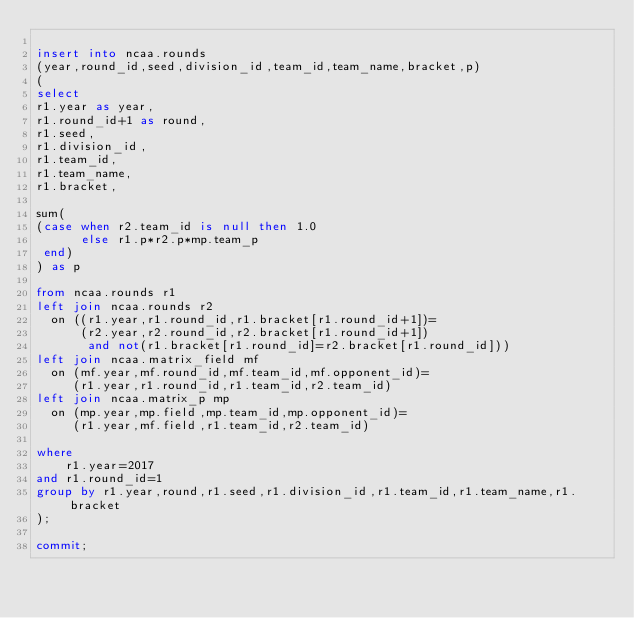<code> <loc_0><loc_0><loc_500><loc_500><_SQL_>
insert into ncaa.rounds
(year,round_id,seed,division_id,team_id,team_name,bracket,p)
(
select
r1.year as year,
r1.round_id+1 as round,
r1.seed,
r1.division_id,
r1.team_id,
r1.team_name,
r1.bracket,

sum(
(case when r2.team_id is null then 1.0
      else r1.p*r2.p*mp.team_p
 end)
) as p

from ncaa.rounds r1
left join ncaa.rounds r2
  on ((r1.year,r1.round_id,r1.bracket[r1.round_id+1])=
      (r2.year,r2.round_id,r2.bracket[r1.round_id+1])
       and not(r1.bracket[r1.round_id]=r2.bracket[r1.round_id]))
left join ncaa.matrix_field mf
  on (mf.year,mf.round_id,mf.team_id,mf.opponent_id)=
     (r1.year,r1.round_id,r1.team_id,r2.team_id)
left join ncaa.matrix_p mp
  on (mp.year,mp.field,mp.team_id,mp.opponent_id)=
     (r1.year,mf.field,r1.team_id,r2.team_id)

where
    r1.year=2017
and r1.round_id=1
group by r1.year,round,r1.seed,r1.division_id,r1.team_id,r1.team_name,r1.bracket
);

commit;
</code> 